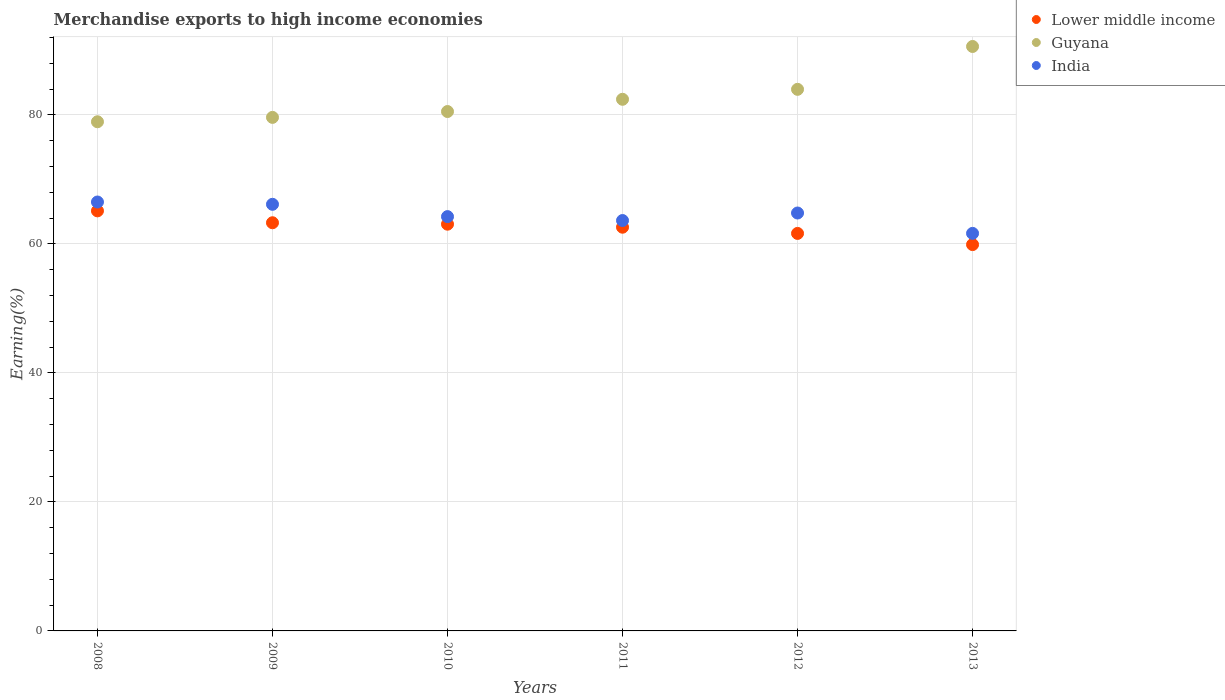Is the number of dotlines equal to the number of legend labels?
Offer a very short reply. Yes. What is the percentage of amount earned from merchandise exports in Guyana in 2009?
Your answer should be very brief. 79.63. Across all years, what is the maximum percentage of amount earned from merchandise exports in India?
Provide a succinct answer. 66.51. Across all years, what is the minimum percentage of amount earned from merchandise exports in India?
Make the answer very short. 61.64. In which year was the percentage of amount earned from merchandise exports in India maximum?
Give a very brief answer. 2008. What is the total percentage of amount earned from merchandise exports in Lower middle income in the graph?
Your answer should be very brief. 375.63. What is the difference between the percentage of amount earned from merchandise exports in Lower middle income in 2009 and that in 2012?
Provide a short and direct response. 1.65. What is the difference between the percentage of amount earned from merchandise exports in Lower middle income in 2012 and the percentage of amount earned from merchandise exports in India in 2008?
Make the answer very short. -4.87. What is the average percentage of amount earned from merchandise exports in Guyana per year?
Your response must be concise. 82.69. In the year 2012, what is the difference between the percentage of amount earned from merchandise exports in India and percentage of amount earned from merchandise exports in Lower middle income?
Give a very brief answer. 3.16. In how many years, is the percentage of amount earned from merchandise exports in Lower middle income greater than 28 %?
Offer a terse response. 6. What is the ratio of the percentage of amount earned from merchandise exports in India in 2011 to that in 2013?
Your answer should be compact. 1.03. What is the difference between the highest and the second highest percentage of amount earned from merchandise exports in Lower middle income?
Provide a succinct answer. 1.84. What is the difference between the highest and the lowest percentage of amount earned from merchandise exports in Lower middle income?
Provide a short and direct response. 5.23. Is it the case that in every year, the sum of the percentage of amount earned from merchandise exports in Guyana and percentage of amount earned from merchandise exports in Lower middle income  is greater than the percentage of amount earned from merchandise exports in India?
Provide a succinct answer. Yes. Does the percentage of amount earned from merchandise exports in Guyana monotonically increase over the years?
Provide a succinct answer. Yes. How many dotlines are there?
Provide a short and direct response. 3. Does the graph contain any zero values?
Give a very brief answer. No. Does the graph contain grids?
Provide a short and direct response. Yes. How are the legend labels stacked?
Your response must be concise. Vertical. What is the title of the graph?
Your answer should be compact. Merchandise exports to high income economies. Does "Heavily indebted poor countries" appear as one of the legend labels in the graph?
Give a very brief answer. No. What is the label or title of the Y-axis?
Your answer should be very brief. Earning(%). What is the Earning(%) of Lower middle income in 2008?
Your response must be concise. 65.13. What is the Earning(%) of Guyana in 2008?
Your answer should be compact. 78.95. What is the Earning(%) of India in 2008?
Your answer should be very brief. 66.51. What is the Earning(%) in Lower middle income in 2009?
Provide a short and direct response. 63.29. What is the Earning(%) in Guyana in 2009?
Ensure brevity in your answer.  79.63. What is the Earning(%) of India in 2009?
Make the answer very short. 66.15. What is the Earning(%) of Lower middle income in 2010?
Offer a terse response. 63.07. What is the Earning(%) of Guyana in 2010?
Offer a very short reply. 80.54. What is the Earning(%) in India in 2010?
Ensure brevity in your answer.  64.24. What is the Earning(%) in Lower middle income in 2011?
Keep it short and to the point. 62.6. What is the Earning(%) of Guyana in 2011?
Provide a succinct answer. 82.43. What is the Earning(%) of India in 2011?
Keep it short and to the point. 63.63. What is the Earning(%) of Lower middle income in 2012?
Your answer should be very brief. 61.64. What is the Earning(%) of Guyana in 2012?
Provide a short and direct response. 83.98. What is the Earning(%) in India in 2012?
Offer a terse response. 64.8. What is the Earning(%) of Lower middle income in 2013?
Ensure brevity in your answer.  59.9. What is the Earning(%) of Guyana in 2013?
Give a very brief answer. 90.62. What is the Earning(%) in India in 2013?
Your answer should be compact. 61.64. Across all years, what is the maximum Earning(%) of Lower middle income?
Give a very brief answer. 65.13. Across all years, what is the maximum Earning(%) in Guyana?
Give a very brief answer. 90.62. Across all years, what is the maximum Earning(%) in India?
Make the answer very short. 66.51. Across all years, what is the minimum Earning(%) in Lower middle income?
Make the answer very short. 59.9. Across all years, what is the minimum Earning(%) in Guyana?
Offer a terse response. 78.95. Across all years, what is the minimum Earning(%) in India?
Offer a very short reply. 61.64. What is the total Earning(%) in Lower middle income in the graph?
Provide a short and direct response. 375.63. What is the total Earning(%) of Guyana in the graph?
Ensure brevity in your answer.  496.14. What is the total Earning(%) in India in the graph?
Provide a succinct answer. 386.97. What is the difference between the Earning(%) of Lower middle income in 2008 and that in 2009?
Your response must be concise. 1.84. What is the difference between the Earning(%) in Guyana in 2008 and that in 2009?
Make the answer very short. -0.68. What is the difference between the Earning(%) in India in 2008 and that in 2009?
Provide a succinct answer. 0.36. What is the difference between the Earning(%) in Lower middle income in 2008 and that in 2010?
Your answer should be very brief. 2.06. What is the difference between the Earning(%) in Guyana in 2008 and that in 2010?
Keep it short and to the point. -1.59. What is the difference between the Earning(%) in India in 2008 and that in 2010?
Make the answer very short. 2.27. What is the difference between the Earning(%) in Lower middle income in 2008 and that in 2011?
Provide a short and direct response. 2.54. What is the difference between the Earning(%) in Guyana in 2008 and that in 2011?
Your answer should be compact. -3.48. What is the difference between the Earning(%) of India in 2008 and that in 2011?
Offer a terse response. 2.87. What is the difference between the Earning(%) of Lower middle income in 2008 and that in 2012?
Provide a succinct answer. 3.5. What is the difference between the Earning(%) of Guyana in 2008 and that in 2012?
Your answer should be very brief. -5.03. What is the difference between the Earning(%) in India in 2008 and that in 2012?
Ensure brevity in your answer.  1.71. What is the difference between the Earning(%) in Lower middle income in 2008 and that in 2013?
Offer a terse response. 5.23. What is the difference between the Earning(%) of Guyana in 2008 and that in 2013?
Your response must be concise. -11.67. What is the difference between the Earning(%) of India in 2008 and that in 2013?
Make the answer very short. 4.86. What is the difference between the Earning(%) of Lower middle income in 2009 and that in 2010?
Provide a short and direct response. 0.22. What is the difference between the Earning(%) of Guyana in 2009 and that in 2010?
Your response must be concise. -0.91. What is the difference between the Earning(%) in India in 2009 and that in 2010?
Ensure brevity in your answer.  1.91. What is the difference between the Earning(%) in Lower middle income in 2009 and that in 2011?
Give a very brief answer. 0.69. What is the difference between the Earning(%) of Guyana in 2009 and that in 2011?
Make the answer very short. -2.8. What is the difference between the Earning(%) in India in 2009 and that in 2011?
Keep it short and to the point. 2.52. What is the difference between the Earning(%) of Lower middle income in 2009 and that in 2012?
Your answer should be compact. 1.65. What is the difference between the Earning(%) in Guyana in 2009 and that in 2012?
Keep it short and to the point. -4.35. What is the difference between the Earning(%) of India in 2009 and that in 2012?
Ensure brevity in your answer.  1.35. What is the difference between the Earning(%) in Lower middle income in 2009 and that in 2013?
Your response must be concise. 3.39. What is the difference between the Earning(%) of Guyana in 2009 and that in 2013?
Ensure brevity in your answer.  -10.99. What is the difference between the Earning(%) of India in 2009 and that in 2013?
Keep it short and to the point. 4.51. What is the difference between the Earning(%) in Lower middle income in 2010 and that in 2011?
Offer a very short reply. 0.47. What is the difference between the Earning(%) of Guyana in 2010 and that in 2011?
Give a very brief answer. -1.9. What is the difference between the Earning(%) in India in 2010 and that in 2011?
Your response must be concise. 0.61. What is the difference between the Earning(%) of Lower middle income in 2010 and that in 2012?
Give a very brief answer. 1.43. What is the difference between the Earning(%) of Guyana in 2010 and that in 2012?
Your response must be concise. -3.44. What is the difference between the Earning(%) in India in 2010 and that in 2012?
Ensure brevity in your answer.  -0.56. What is the difference between the Earning(%) in Lower middle income in 2010 and that in 2013?
Give a very brief answer. 3.17. What is the difference between the Earning(%) in Guyana in 2010 and that in 2013?
Offer a very short reply. -10.09. What is the difference between the Earning(%) of India in 2010 and that in 2013?
Provide a short and direct response. 2.6. What is the difference between the Earning(%) in Lower middle income in 2011 and that in 2012?
Your answer should be compact. 0.96. What is the difference between the Earning(%) of Guyana in 2011 and that in 2012?
Provide a succinct answer. -1.54. What is the difference between the Earning(%) of India in 2011 and that in 2012?
Keep it short and to the point. -1.17. What is the difference between the Earning(%) in Lower middle income in 2011 and that in 2013?
Your response must be concise. 2.69. What is the difference between the Earning(%) in Guyana in 2011 and that in 2013?
Make the answer very short. -8.19. What is the difference between the Earning(%) of India in 2011 and that in 2013?
Offer a very short reply. 1.99. What is the difference between the Earning(%) of Lower middle income in 2012 and that in 2013?
Provide a succinct answer. 1.73. What is the difference between the Earning(%) of Guyana in 2012 and that in 2013?
Your answer should be compact. -6.64. What is the difference between the Earning(%) in India in 2012 and that in 2013?
Offer a very short reply. 3.16. What is the difference between the Earning(%) of Lower middle income in 2008 and the Earning(%) of Guyana in 2009?
Make the answer very short. -14.49. What is the difference between the Earning(%) of Lower middle income in 2008 and the Earning(%) of India in 2009?
Offer a terse response. -1.02. What is the difference between the Earning(%) of Guyana in 2008 and the Earning(%) of India in 2009?
Your answer should be compact. 12.8. What is the difference between the Earning(%) in Lower middle income in 2008 and the Earning(%) in Guyana in 2010?
Provide a succinct answer. -15.4. What is the difference between the Earning(%) in Lower middle income in 2008 and the Earning(%) in India in 2010?
Your answer should be compact. 0.89. What is the difference between the Earning(%) in Guyana in 2008 and the Earning(%) in India in 2010?
Your answer should be compact. 14.71. What is the difference between the Earning(%) in Lower middle income in 2008 and the Earning(%) in Guyana in 2011?
Provide a succinct answer. -17.3. What is the difference between the Earning(%) in Lower middle income in 2008 and the Earning(%) in India in 2011?
Your response must be concise. 1.5. What is the difference between the Earning(%) of Guyana in 2008 and the Earning(%) of India in 2011?
Offer a very short reply. 15.31. What is the difference between the Earning(%) in Lower middle income in 2008 and the Earning(%) in Guyana in 2012?
Provide a succinct answer. -18.84. What is the difference between the Earning(%) in Lower middle income in 2008 and the Earning(%) in India in 2012?
Your response must be concise. 0.33. What is the difference between the Earning(%) in Guyana in 2008 and the Earning(%) in India in 2012?
Give a very brief answer. 14.15. What is the difference between the Earning(%) in Lower middle income in 2008 and the Earning(%) in Guyana in 2013?
Your response must be concise. -25.49. What is the difference between the Earning(%) of Lower middle income in 2008 and the Earning(%) of India in 2013?
Offer a very short reply. 3.49. What is the difference between the Earning(%) in Guyana in 2008 and the Earning(%) in India in 2013?
Offer a terse response. 17.31. What is the difference between the Earning(%) of Lower middle income in 2009 and the Earning(%) of Guyana in 2010?
Provide a short and direct response. -17.25. What is the difference between the Earning(%) of Lower middle income in 2009 and the Earning(%) of India in 2010?
Offer a terse response. -0.95. What is the difference between the Earning(%) in Guyana in 2009 and the Earning(%) in India in 2010?
Provide a short and direct response. 15.39. What is the difference between the Earning(%) in Lower middle income in 2009 and the Earning(%) in Guyana in 2011?
Ensure brevity in your answer.  -19.14. What is the difference between the Earning(%) in Lower middle income in 2009 and the Earning(%) in India in 2011?
Keep it short and to the point. -0.34. What is the difference between the Earning(%) of Guyana in 2009 and the Earning(%) of India in 2011?
Your answer should be very brief. 15.99. What is the difference between the Earning(%) in Lower middle income in 2009 and the Earning(%) in Guyana in 2012?
Offer a very short reply. -20.69. What is the difference between the Earning(%) of Lower middle income in 2009 and the Earning(%) of India in 2012?
Provide a succinct answer. -1.51. What is the difference between the Earning(%) of Guyana in 2009 and the Earning(%) of India in 2012?
Your response must be concise. 14.83. What is the difference between the Earning(%) in Lower middle income in 2009 and the Earning(%) in Guyana in 2013?
Offer a very short reply. -27.33. What is the difference between the Earning(%) of Lower middle income in 2009 and the Earning(%) of India in 2013?
Your answer should be very brief. 1.65. What is the difference between the Earning(%) in Guyana in 2009 and the Earning(%) in India in 2013?
Your answer should be very brief. 17.99. What is the difference between the Earning(%) in Lower middle income in 2010 and the Earning(%) in Guyana in 2011?
Provide a succinct answer. -19.36. What is the difference between the Earning(%) of Lower middle income in 2010 and the Earning(%) of India in 2011?
Provide a succinct answer. -0.57. What is the difference between the Earning(%) of Guyana in 2010 and the Earning(%) of India in 2011?
Offer a terse response. 16.9. What is the difference between the Earning(%) in Lower middle income in 2010 and the Earning(%) in Guyana in 2012?
Your answer should be compact. -20.91. What is the difference between the Earning(%) in Lower middle income in 2010 and the Earning(%) in India in 2012?
Give a very brief answer. -1.73. What is the difference between the Earning(%) in Guyana in 2010 and the Earning(%) in India in 2012?
Your answer should be very brief. 15.74. What is the difference between the Earning(%) of Lower middle income in 2010 and the Earning(%) of Guyana in 2013?
Keep it short and to the point. -27.55. What is the difference between the Earning(%) of Lower middle income in 2010 and the Earning(%) of India in 2013?
Offer a terse response. 1.43. What is the difference between the Earning(%) in Guyana in 2010 and the Earning(%) in India in 2013?
Ensure brevity in your answer.  18.89. What is the difference between the Earning(%) of Lower middle income in 2011 and the Earning(%) of Guyana in 2012?
Your answer should be compact. -21.38. What is the difference between the Earning(%) in Lower middle income in 2011 and the Earning(%) in India in 2012?
Your answer should be very brief. -2.2. What is the difference between the Earning(%) of Guyana in 2011 and the Earning(%) of India in 2012?
Provide a short and direct response. 17.63. What is the difference between the Earning(%) in Lower middle income in 2011 and the Earning(%) in Guyana in 2013?
Make the answer very short. -28.02. What is the difference between the Earning(%) of Lower middle income in 2011 and the Earning(%) of India in 2013?
Make the answer very short. 0.96. What is the difference between the Earning(%) in Guyana in 2011 and the Earning(%) in India in 2013?
Your response must be concise. 20.79. What is the difference between the Earning(%) of Lower middle income in 2012 and the Earning(%) of Guyana in 2013?
Ensure brevity in your answer.  -28.99. What is the difference between the Earning(%) of Lower middle income in 2012 and the Earning(%) of India in 2013?
Give a very brief answer. -0.01. What is the difference between the Earning(%) in Guyana in 2012 and the Earning(%) in India in 2013?
Your answer should be compact. 22.34. What is the average Earning(%) in Lower middle income per year?
Ensure brevity in your answer.  62.6. What is the average Earning(%) in Guyana per year?
Ensure brevity in your answer.  82.69. What is the average Earning(%) of India per year?
Ensure brevity in your answer.  64.5. In the year 2008, what is the difference between the Earning(%) of Lower middle income and Earning(%) of Guyana?
Give a very brief answer. -13.81. In the year 2008, what is the difference between the Earning(%) in Lower middle income and Earning(%) in India?
Ensure brevity in your answer.  -1.37. In the year 2008, what is the difference between the Earning(%) of Guyana and Earning(%) of India?
Offer a terse response. 12.44. In the year 2009, what is the difference between the Earning(%) of Lower middle income and Earning(%) of Guyana?
Make the answer very short. -16.34. In the year 2009, what is the difference between the Earning(%) of Lower middle income and Earning(%) of India?
Your response must be concise. -2.86. In the year 2009, what is the difference between the Earning(%) in Guyana and Earning(%) in India?
Offer a terse response. 13.48. In the year 2010, what is the difference between the Earning(%) in Lower middle income and Earning(%) in Guyana?
Make the answer very short. -17.47. In the year 2010, what is the difference between the Earning(%) in Lower middle income and Earning(%) in India?
Offer a very short reply. -1.17. In the year 2010, what is the difference between the Earning(%) of Guyana and Earning(%) of India?
Your response must be concise. 16.3. In the year 2011, what is the difference between the Earning(%) in Lower middle income and Earning(%) in Guyana?
Ensure brevity in your answer.  -19.83. In the year 2011, what is the difference between the Earning(%) of Lower middle income and Earning(%) of India?
Keep it short and to the point. -1.04. In the year 2011, what is the difference between the Earning(%) of Guyana and Earning(%) of India?
Provide a short and direct response. 18.8. In the year 2012, what is the difference between the Earning(%) of Lower middle income and Earning(%) of Guyana?
Provide a short and direct response. -22.34. In the year 2012, what is the difference between the Earning(%) of Lower middle income and Earning(%) of India?
Provide a short and direct response. -3.16. In the year 2012, what is the difference between the Earning(%) in Guyana and Earning(%) in India?
Your response must be concise. 19.18. In the year 2013, what is the difference between the Earning(%) in Lower middle income and Earning(%) in Guyana?
Offer a terse response. -30.72. In the year 2013, what is the difference between the Earning(%) of Lower middle income and Earning(%) of India?
Offer a terse response. -1.74. In the year 2013, what is the difference between the Earning(%) in Guyana and Earning(%) in India?
Provide a succinct answer. 28.98. What is the ratio of the Earning(%) of Lower middle income in 2008 to that in 2009?
Your answer should be very brief. 1.03. What is the ratio of the Earning(%) in India in 2008 to that in 2009?
Your answer should be compact. 1.01. What is the ratio of the Earning(%) in Lower middle income in 2008 to that in 2010?
Provide a short and direct response. 1.03. What is the ratio of the Earning(%) in Guyana in 2008 to that in 2010?
Your answer should be compact. 0.98. What is the ratio of the Earning(%) of India in 2008 to that in 2010?
Give a very brief answer. 1.04. What is the ratio of the Earning(%) of Lower middle income in 2008 to that in 2011?
Provide a succinct answer. 1.04. What is the ratio of the Earning(%) in Guyana in 2008 to that in 2011?
Keep it short and to the point. 0.96. What is the ratio of the Earning(%) of India in 2008 to that in 2011?
Keep it short and to the point. 1.05. What is the ratio of the Earning(%) in Lower middle income in 2008 to that in 2012?
Your answer should be compact. 1.06. What is the ratio of the Earning(%) of Guyana in 2008 to that in 2012?
Provide a succinct answer. 0.94. What is the ratio of the Earning(%) in India in 2008 to that in 2012?
Offer a terse response. 1.03. What is the ratio of the Earning(%) of Lower middle income in 2008 to that in 2013?
Ensure brevity in your answer.  1.09. What is the ratio of the Earning(%) of Guyana in 2008 to that in 2013?
Provide a succinct answer. 0.87. What is the ratio of the Earning(%) in India in 2008 to that in 2013?
Provide a short and direct response. 1.08. What is the ratio of the Earning(%) of Lower middle income in 2009 to that in 2010?
Ensure brevity in your answer.  1. What is the ratio of the Earning(%) of Guyana in 2009 to that in 2010?
Offer a terse response. 0.99. What is the ratio of the Earning(%) in India in 2009 to that in 2010?
Your response must be concise. 1.03. What is the ratio of the Earning(%) in Lower middle income in 2009 to that in 2011?
Your answer should be compact. 1.01. What is the ratio of the Earning(%) in India in 2009 to that in 2011?
Provide a succinct answer. 1.04. What is the ratio of the Earning(%) of Lower middle income in 2009 to that in 2012?
Give a very brief answer. 1.03. What is the ratio of the Earning(%) in Guyana in 2009 to that in 2012?
Your response must be concise. 0.95. What is the ratio of the Earning(%) in India in 2009 to that in 2012?
Make the answer very short. 1.02. What is the ratio of the Earning(%) of Lower middle income in 2009 to that in 2013?
Your answer should be compact. 1.06. What is the ratio of the Earning(%) in Guyana in 2009 to that in 2013?
Ensure brevity in your answer.  0.88. What is the ratio of the Earning(%) in India in 2009 to that in 2013?
Give a very brief answer. 1.07. What is the ratio of the Earning(%) in Lower middle income in 2010 to that in 2011?
Make the answer very short. 1.01. What is the ratio of the Earning(%) of India in 2010 to that in 2011?
Ensure brevity in your answer.  1.01. What is the ratio of the Earning(%) of Lower middle income in 2010 to that in 2012?
Make the answer very short. 1.02. What is the ratio of the Earning(%) of Lower middle income in 2010 to that in 2013?
Make the answer very short. 1.05. What is the ratio of the Earning(%) in Guyana in 2010 to that in 2013?
Keep it short and to the point. 0.89. What is the ratio of the Earning(%) in India in 2010 to that in 2013?
Your answer should be compact. 1.04. What is the ratio of the Earning(%) in Lower middle income in 2011 to that in 2012?
Provide a short and direct response. 1.02. What is the ratio of the Earning(%) of Guyana in 2011 to that in 2012?
Give a very brief answer. 0.98. What is the ratio of the Earning(%) of Lower middle income in 2011 to that in 2013?
Make the answer very short. 1.04. What is the ratio of the Earning(%) of Guyana in 2011 to that in 2013?
Provide a succinct answer. 0.91. What is the ratio of the Earning(%) of India in 2011 to that in 2013?
Your response must be concise. 1.03. What is the ratio of the Earning(%) of Lower middle income in 2012 to that in 2013?
Ensure brevity in your answer.  1.03. What is the ratio of the Earning(%) in Guyana in 2012 to that in 2013?
Offer a terse response. 0.93. What is the ratio of the Earning(%) in India in 2012 to that in 2013?
Your response must be concise. 1.05. What is the difference between the highest and the second highest Earning(%) of Lower middle income?
Ensure brevity in your answer.  1.84. What is the difference between the highest and the second highest Earning(%) of Guyana?
Ensure brevity in your answer.  6.64. What is the difference between the highest and the second highest Earning(%) in India?
Give a very brief answer. 0.36. What is the difference between the highest and the lowest Earning(%) in Lower middle income?
Ensure brevity in your answer.  5.23. What is the difference between the highest and the lowest Earning(%) in Guyana?
Give a very brief answer. 11.67. What is the difference between the highest and the lowest Earning(%) in India?
Provide a short and direct response. 4.86. 